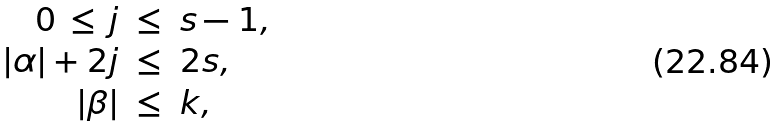<formula> <loc_0><loc_0><loc_500><loc_500>\begin{array} { r c l } 0 \, \leq \, j & \leq & s - 1 , \\ | \alpha | + 2 j & \leq & 2 s , \\ | \beta | & \leq & k , \end{array}</formula> 